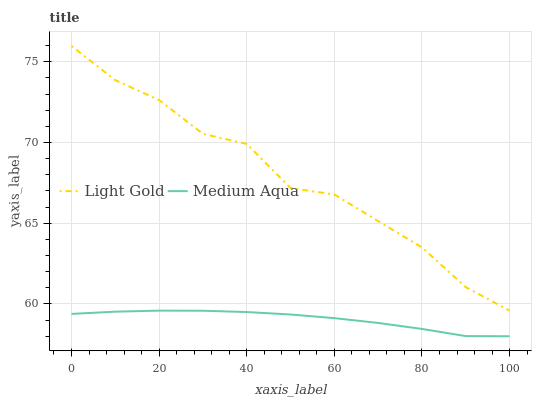Does Medium Aqua have the minimum area under the curve?
Answer yes or no. Yes. Does Light Gold have the maximum area under the curve?
Answer yes or no. Yes. Does Light Gold have the minimum area under the curve?
Answer yes or no. No. Is Medium Aqua the smoothest?
Answer yes or no. Yes. Is Light Gold the roughest?
Answer yes or no. Yes. Is Light Gold the smoothest?
Answer yes or no. No. Does Medium Aqua have the lowest value?
Answer yes or no. Yes. Does Light Gold have the lowest value?
Answer yes or no. No. Does Light Gold have the highest value?
Answer yes or no. Yes. Is Medium Aqua less than Light Gold?
Answer yes or no. Yes. Is Light Gold greater than Medium Aqua?
Answer yes or no. Yes. Does Medium Aqua intersect Light Gold?
Answer yes or no. No. 